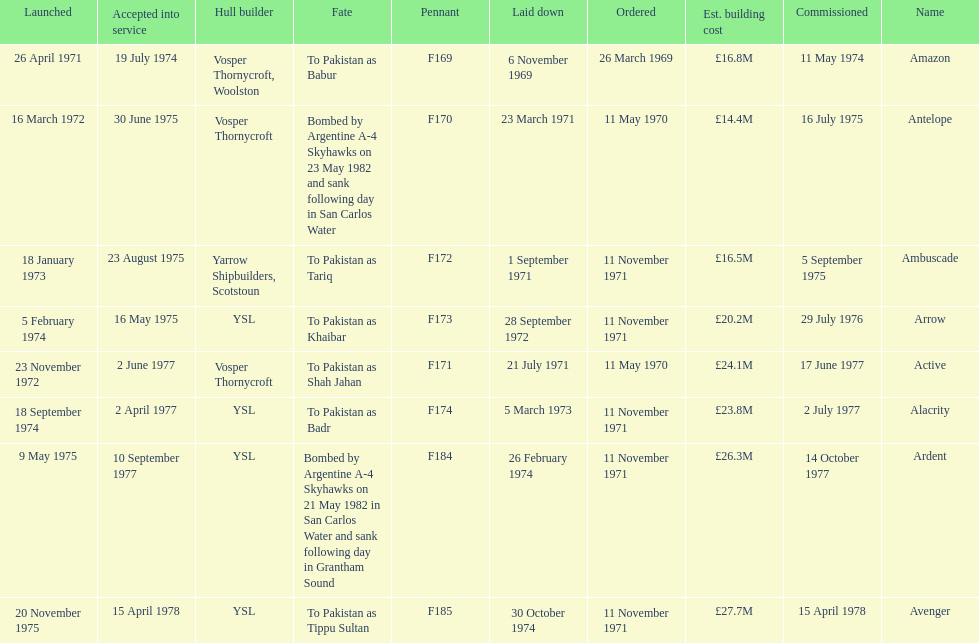How many ships were built after ardent? 1. 